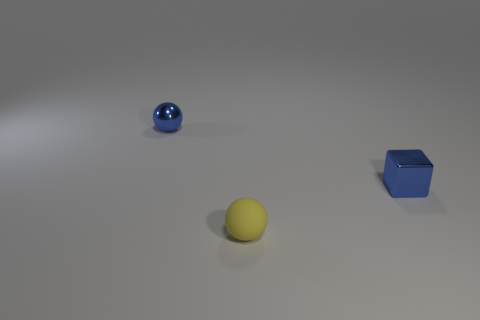Is the number of small green metal cylinders less than the number of small blue metal spheres?
Ensure brevity in your answer.  Yes. There is a object that is left of the yellow rubber object; is its color the same as the rubber ball?
Ensure brevity in your answer.  No. How many metallic cubes are the same size as the yellow matte object?
Your answer should be compact. 1. Are there any objects that have the same color as the tiny shiny sphere?
Keep it short and to the point. Yes. Is the tiny yellow ball made of the same material as the small blue cube?
Keep it short and to the point. No. What number of metal objects are the same shape as the yellow matte object?
Keep it short and to the point. 1. What is the shape of the object that is the same material as the block?
Give a very brief answer. Sphere. What color is the small thing that is in front of the tiny metallic thing that is in front of the tiny blue sphere?
Give a very brief answer. Yellow. Do the small shiny cube and the matte thing have the same color?
Make the answer very short. No. There is a ball in front of the blue shiny thing behind the small cube; what is it made of?
Offer a terse response. Rubber. 